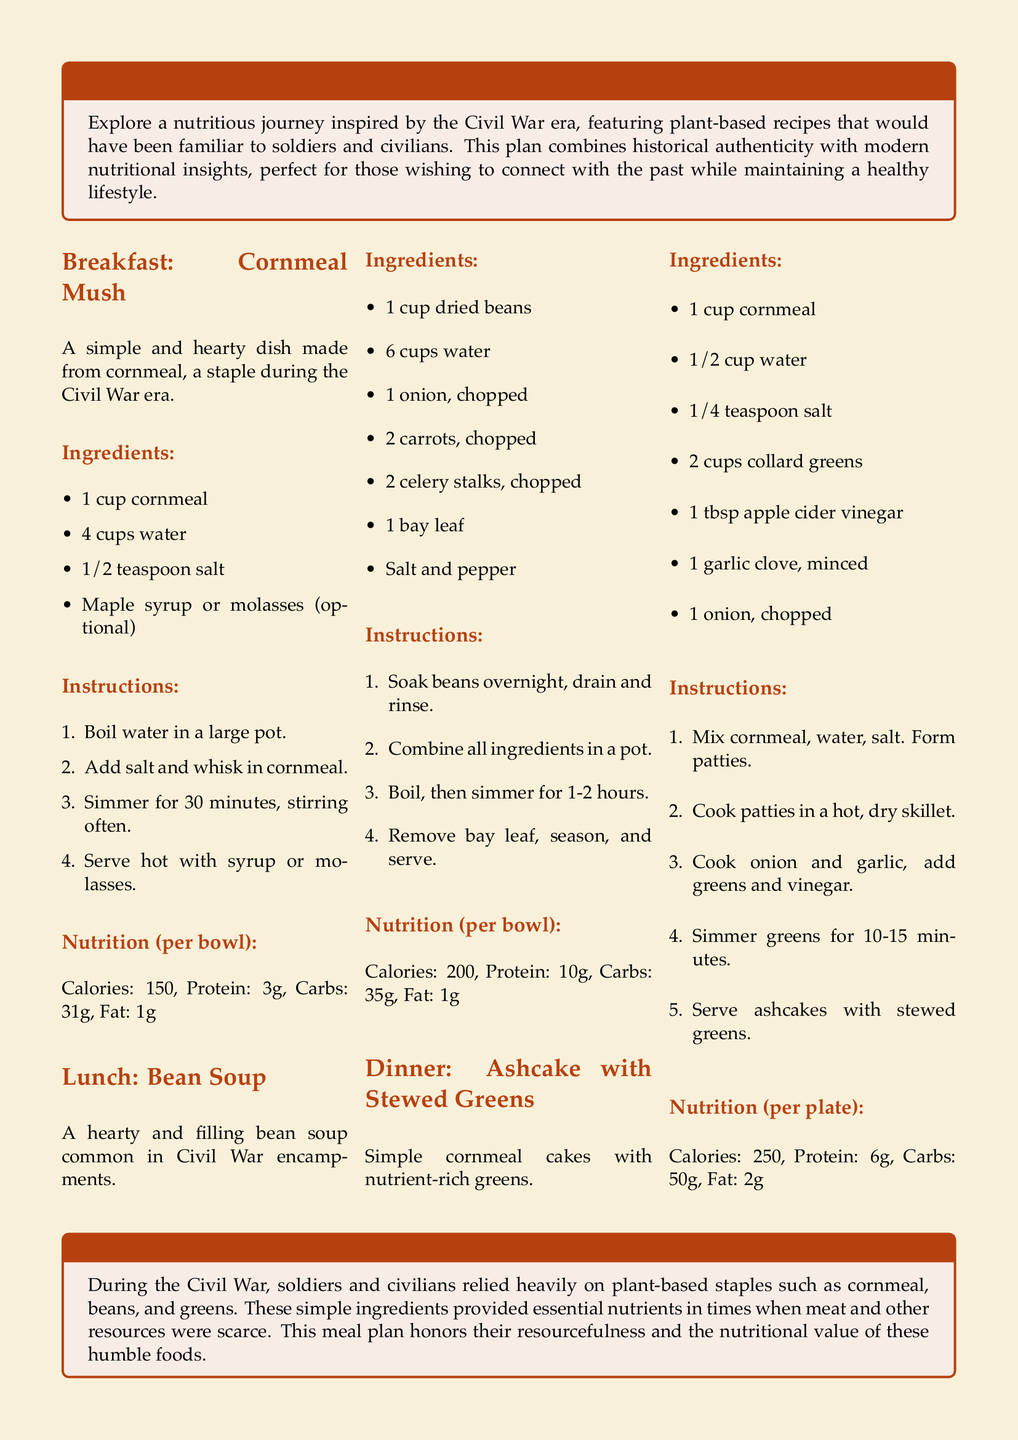What is the first meal listed in the meal plan? The first meal in the plan is labeled as "Breakfast" and features Cornmeal Mush.
Answer: Cornmeal Mush How many cups of water are needed for the breakfast recipe? The recipe for Cornmeal Mush states that 4 cups of water are required.
Answer: 4 cups What is a key ingredient in the Lunch recipe? The bean soup recipe includes dried beans as a key ingredient.
Answer: Dried beans What is the total cooking time for the Bean Soup? The document specifies a cooking time of 1-2 hours for the Bean Soup.
Answer: 1-2 hours How many grams of protein are in the Dinner meal? The nutrition section for the Dinner dish states it has 6 grams of protein per plate.
Answer: 6g What cooking method is used for the cornmeal patties? The instructions indicate that the patties are cooked in a hot, dry skillet.
Answer: Hot, dry skillet What is the main historical focus of the meal plan? The meal plan connects modern meals with historical recipes from the Civil War era.
Answer: Civil War era How is the nutritional information presented in the document? The nutrition details are provided as part of each meal section, listing calories, protein, carbs, and fat.
Answer: Nutrition details per meal 